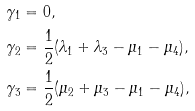<formula> <loc_0><loc_0><loc_500><loc_500>\gamma _ { 1 } & = 0 , \\ \gamma _ { 2 } & = \frac { 1 } { 2 } ( \lambda _ { 1 } + \lambda _ { 3 } - \mu _ { 1 } - \mu _ { 4 } ) , \\ \gamma _ { 3 } & = \frac { 1 } { 2 } ( \mu _ { 2 } + \mu _ { 3 } - \mu _ { 1 } - \mu _ { 4 } ) ,</formula> 